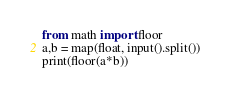<code> <loc_0><loc_0><loc_500><loc_500><_Python_>from math import floor
a,b = map(float, input().split())
print(floor(a*b))</code> 